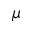<formula> <loc_0><loc_0><loc_500><loc_500>\mu</formula> 